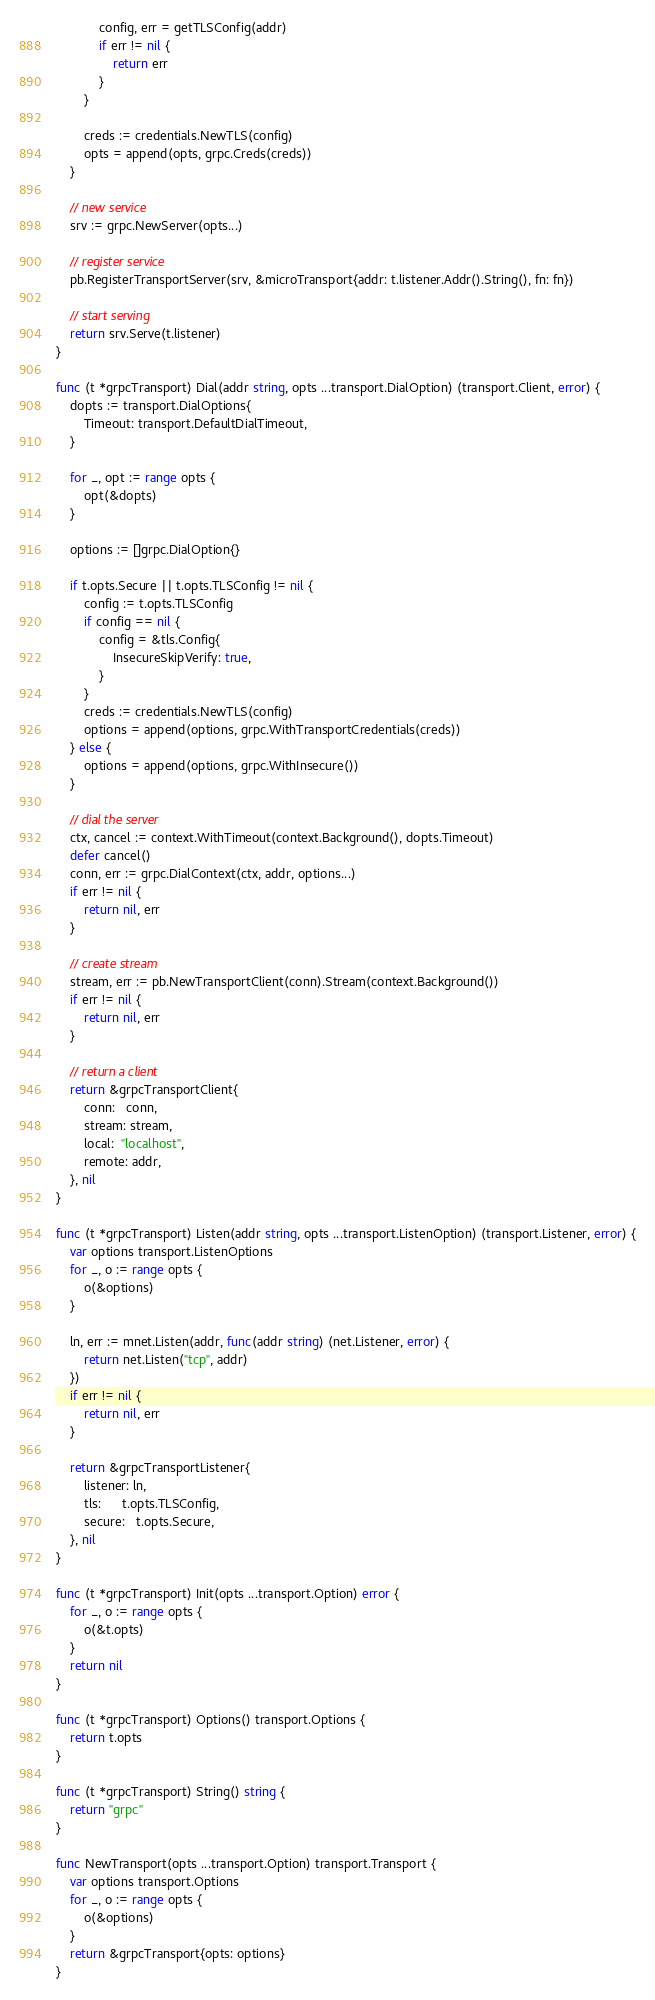<code> <loc_0><loc_0><loc_500><loc_500><_Go_>			config, err = getTLSConfig(addr)
			if err != nil {
				return err
			}
		}

		creds := credentials.NewTLS(config)
		opts = append(opts, grpc.Creds(creds))
	}

	// new service
	srv := grpc.NewServer(opts...)

	// register service
	pb.RegisterTransportServer(srv, &microTransport{addr: t.listener.Addr().String(), fn: fn})

	// start serving
	return srv.Serve(t.listener)
}

func (t *grpcTransport) Dial(addr string, opts ...transport.DialOption) (transport.Client, error) {
	dopts := transport.DialOptions{
		Timeout: transport.DefaultDialTimeout,
	}

	for _, opt := range opts {
		opt(&dopts)
	}

	options := []grpc.DialOption{}

	if t.opts.Secure || t.opts.TLSConfig != nil {
		config := t.opts.TLSConfig
		if config == nil {
			config = &tls.Config{
				InsecureSkipVerify: true,
			}
		}
		creds := credentials.NewTLS(config)
		options = append(options, grpc.WithTransportCredentials(creds))
	} else {
		options = append(options, grpc.WithInsecure())
	}

	// dial the server
	ctx, cancel := context.WithTimeout(context.Background(), dopts.Timeout)
	defer cancel()
	conn, err := grpc.DialContext(ctx, addr, options...)
	if err != nil {
		return nil, err
	}

	// create stream
	stream, err := pb.NewTransportClient(conn).Stream(context.Background())
	if err != nil {
		return nil, err
	}

	// return a client
	return &grpcTransportClient{
		conn:   conn,
		stream: stream,
		local:  "localhost",
		remote: addr,
	}, nil
}

func (t *grpcTransport) Listen(addr string, opts ...transport.ListenOption) (transport.Listener, error) {
	var options transport.ListenOptions
	for _, o := range opts {
		o(&options)
	}

	ln, err := mnet.Listen(addr, func(addr string) (net.Listener, error) {
		return net.Listen("tcp", addr)
	})
	if err != nil {
		return nil, err
	}

	return &grpcTransportListener{
		listener: ln,
		tls:      t.opts.TLSConfig,
		secure:   t.opts.Secure,
	}, nil
}

func (t *grpcTransport) Init(opts ...transport.Option) error {
	for _, o := range opts {
		o(&t.opts)
	}
	return nil
}

func (t *grpcTransport) Options() transport.Options {
	return t.opts
}

func (t *grpcTransport) String() string {
	return "grpc"
}

func NewTransport(opts ...transport.Option) transport.Transport {
	var options transport.Options
	for _, o := range opts {
		o(&options)
	}
	return &grpcTransport{opts: options}
}
</code> 